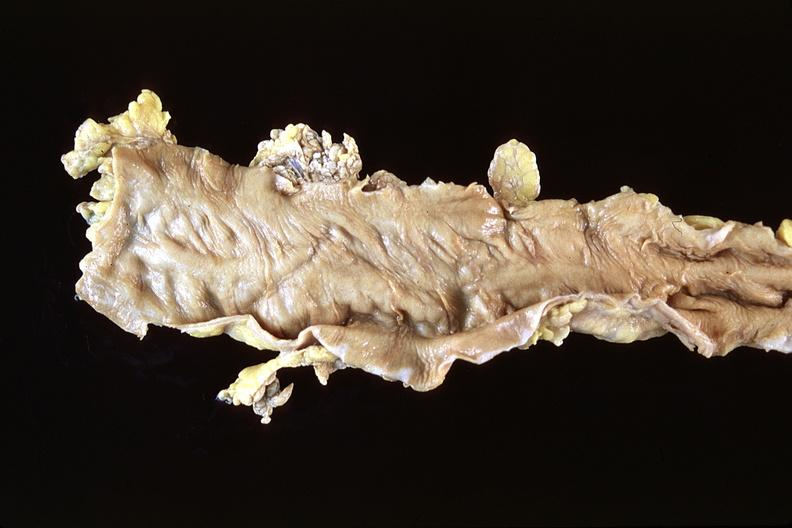what is present?
Answer the question using a single word or phrase. Gastrointestinal 